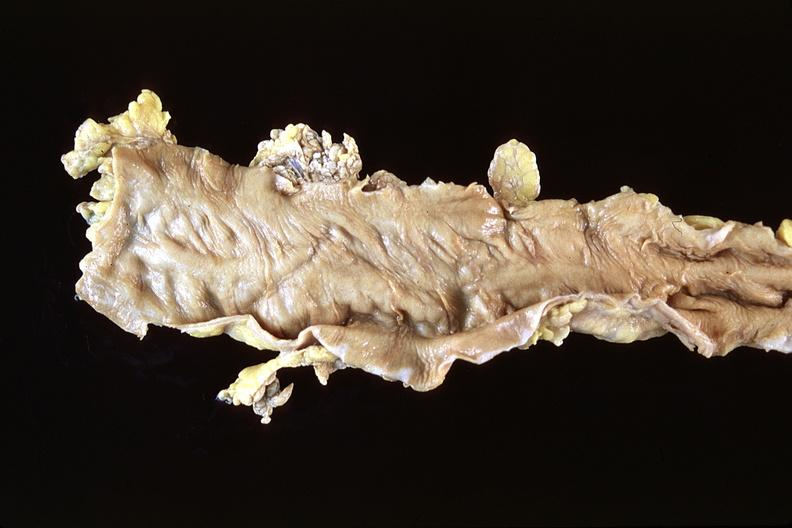what is present?
Answer the question using a single word or phrase. Gastrointestinal 